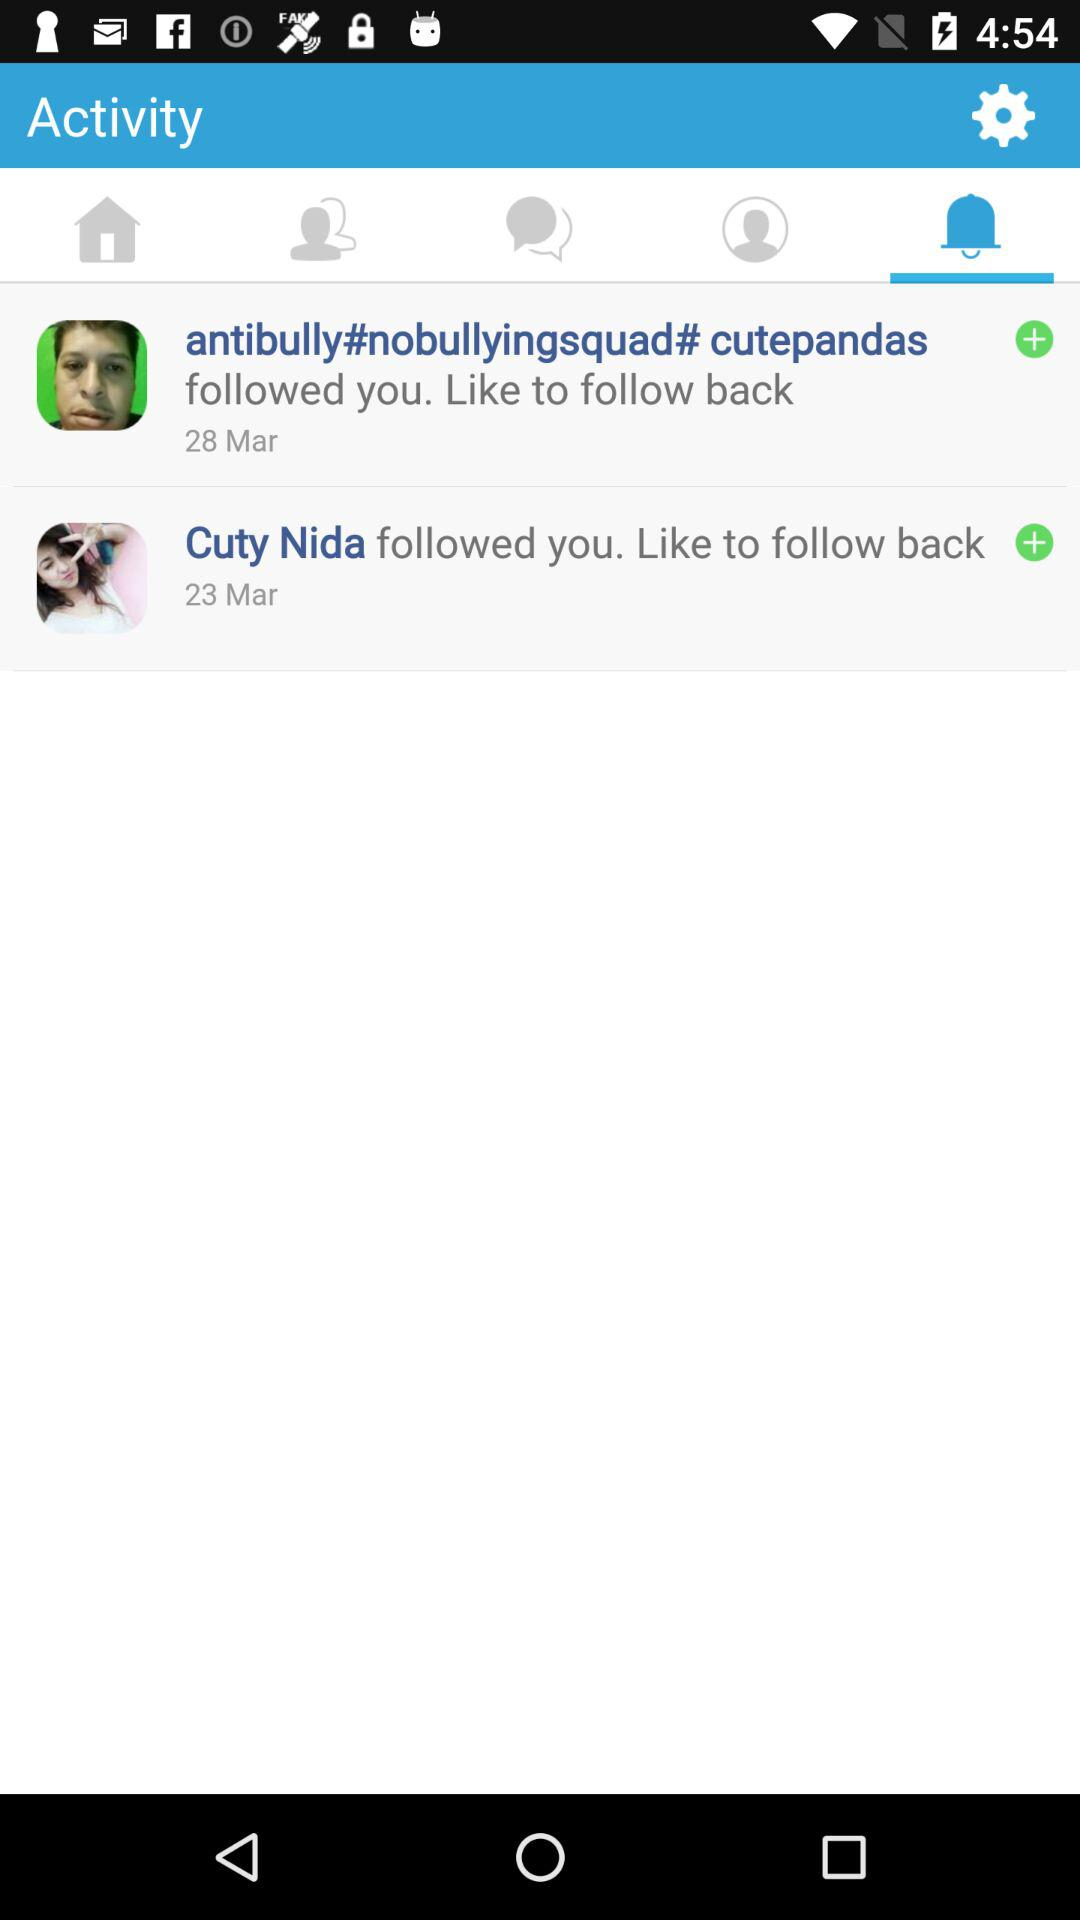Who followed me on March 28? On March 28, "antibully#nobullyingsquad# cutepandas" followed you. 